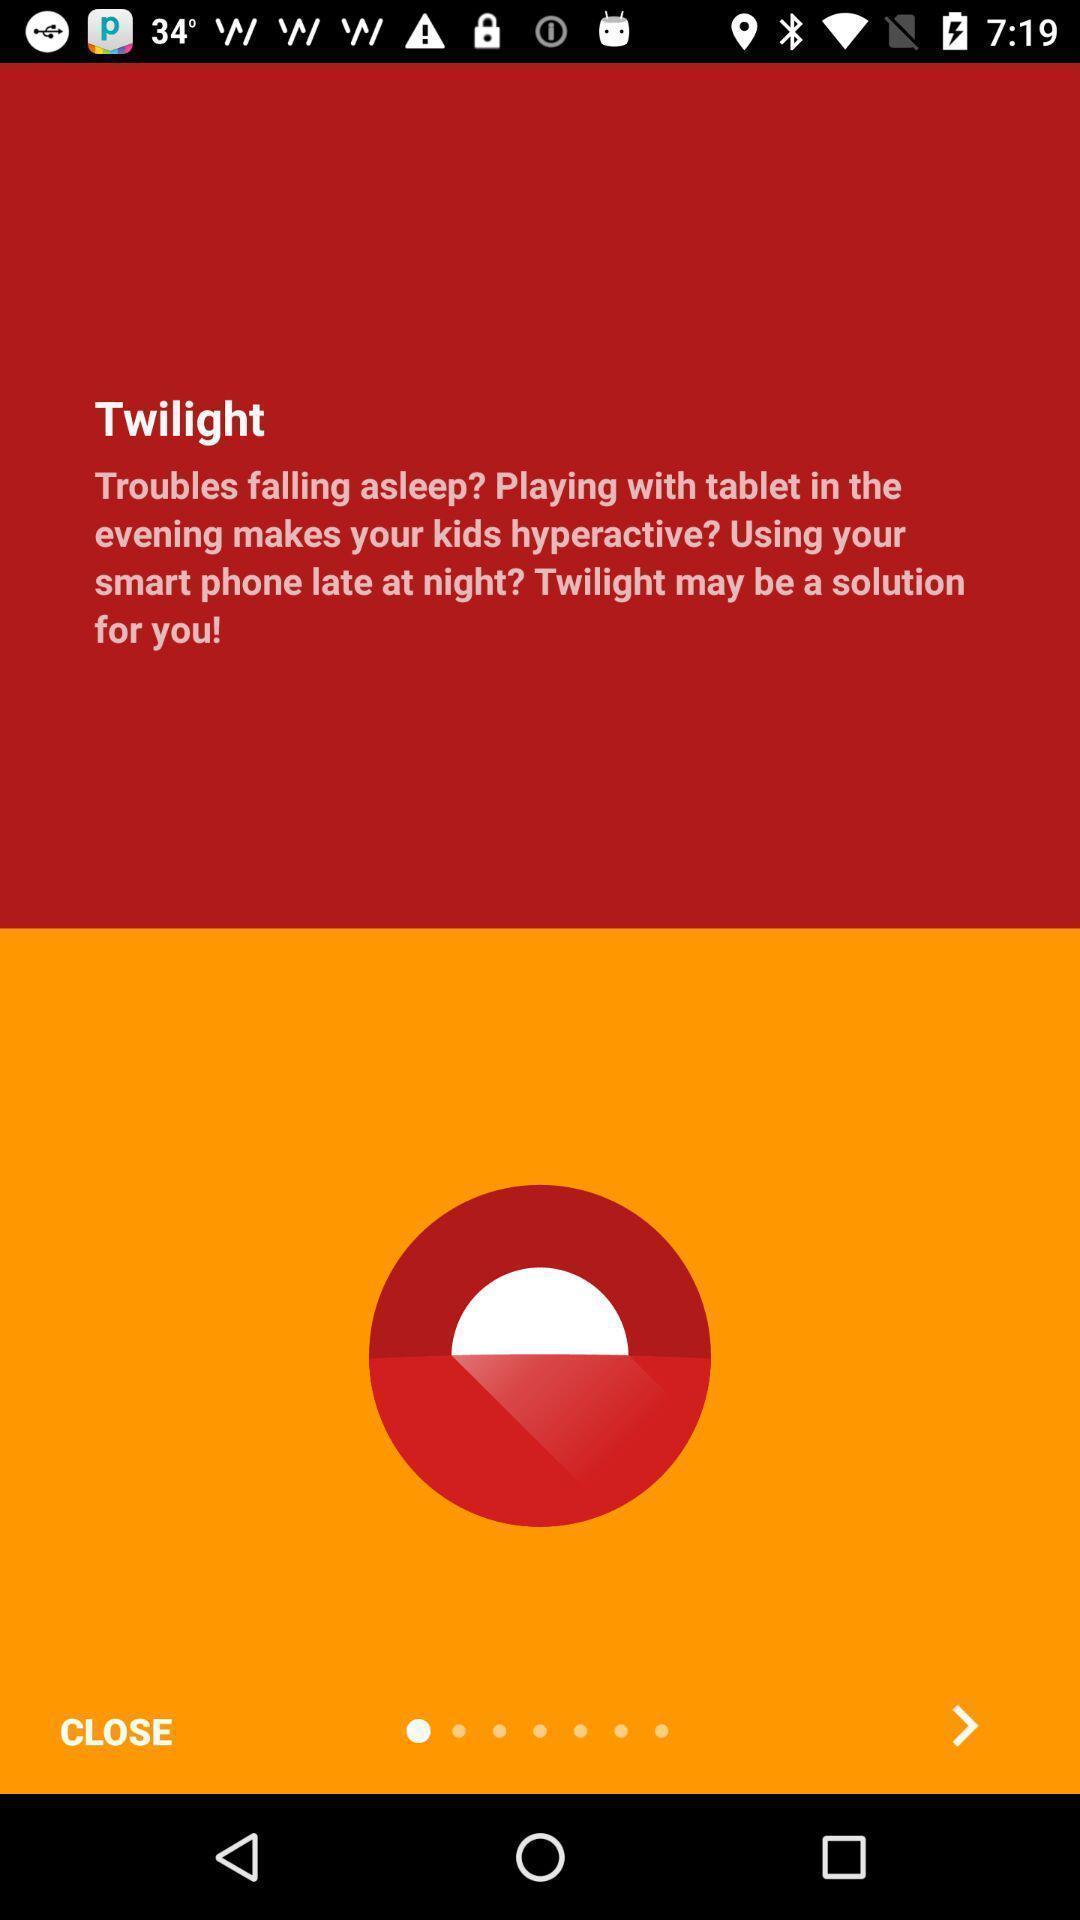Provide a description of this screenshot. Screen shows text message in a kids app. 